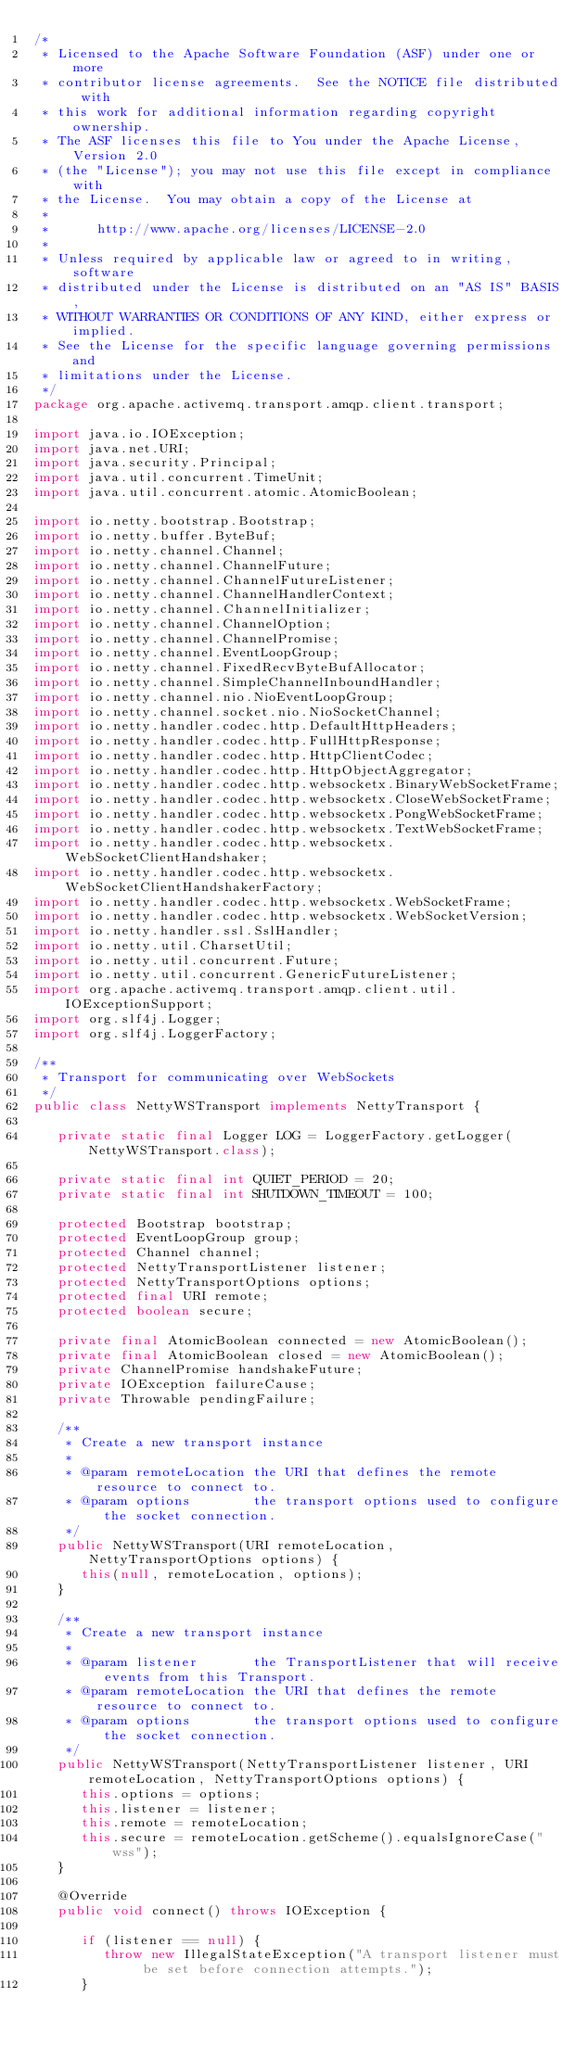<code> <loc_0><loc_0><loc_500><loc_500><_Java_>/*
 * Licensed to the Apache Software Foundation (ASF) under one or more
 * contributor license agreements.  See the NOTICE file distributed with
 * this work for additional information regarding copyright ownership.
 * The ASF licenses this file to You under the Apache License, Version 2.0
 * (the "License"); you may not use this file except in compliance with
 * the License.  You may obtain a copy of the License at
 *
 *      http://www.apache.org/licenses/LICENSE-2.0
 *
 * Unless required by applicable law or agreed to in writing, software
 * distributed under the License is distributed on an "AS IS" BASIS,
 * WITHOUT WARRANTIES OR CONDITIONS OF ANY KIND, either express or implied.
 * See the License for the specific language governing permissions and
 * limitations under the License.
 */
package org.apache.activemq.transport.amqp.client.transport;

import java.io.IOException;
import java.net.URI;
import java.security.Principal;
import java.util.concurrent.TimeUnit;
import java.util.concurrent.atomic.AtomicBoolean;

import io.netty.bootstrap.Bootstrap;
import io.netty.buffer.ByteBuf;
import io.netty.channel.Channel;
import io.netty.channel.ChannelFuture;
import io.netty.channel.ChannelFutureListener;
import io.netty.channel.ChannelHandlerContext;
import io.netty.channel.ChannelInitializer;
import io.netty.channel.ChannelOption;
import io.netty.channel.ChannelPromise;
import io.netty.channel.EventLoopGroup;
import io.netty.channel.FixedRecvByteBufAllocator;
import io.netty.channel.SimpleChannelInboundHandler;
import io.netty.channel.nio.NioEventLoopGroup;
import io.netty.channel.socket.nio.NioSocketChannel;
import io.netty.handler.codec.http.DefaultHttpHeaders;
import io.netty.handler.codec.http.FullHttpResponse;
import io.netty.handler.codec.http.HttpClientCodec;
import io.netty.handler.codec.http.HttpObjectAggregator;
import io.netty.handler.codec.http.websocketx.BinaryWebSocketFrame;
import io.netty.handler.codec.http.websocketx.CloseWebSocketFrame;
import io.netty.handler.codec.http.websocketx.PongWebSocketFrame;
import io.netty.handler.codec.http.websocketx.TextWebSocketFrame;
import io.netty.handler.codec.http.websocketx.WebSocketClientHandshaker;
import io.netty.handler.codec.http.websocketx.WebSocketClientHandshakerFactory;
import io.netty.handler.codec.http.websocketx.WebSocketFrame;
import io.netty.handler.codec.http.websocketx.WebSocketVersion;
import io.netty.handler.ssl.SslHandler;
import io.netty.util.CharsetUtil;
import io.netty.util.concurrent.Future;
import io.netty.util.concurrent.GenericFutureListener;
import org.apache.activemq.transport.amqp.client.util.IOExceptionSupport;
import org.slf4j.Logger;
import org.slf4j.LoggerFactory;

/**
 * Transport for communicating over WebSockets
 */
public class NettyWSTransport implements NettyTransport {

   private static final Logger LOG = LoggerFactory.getLogger(NettyWSTransport.class);

   private static final int QUIET_PERIOD = 20;
   private static final int SHUTDOWN_TIMEOUT = 100;

   protected Bootstrap bootstrap;
   protected EventLoopGroup group;
   protected Channel channel;
   protected NettyTransportListener listener;
   protected NettyTransportOptions options;
   protected final URI remote;
   protected boolean secure;

   private final AtomicBoolean connected = new AtomicBoolean();
   private final AtomicBoolean closed = new AtomicBoolean();
   private ChannelPromise handshakeFuture;
   private IOException failureCause;
   private Throwable pendingFailure;

   /**
    * Create a new transport instance
    *
    * @param remoteLocation the URI that defines the remote resource to connect to.
    * @param options        the transport options used to configure the socket connection.
    */
   public NettyWSTransport(URI remoteLocation, NettyTransportOptions options) {
      this(null, remoteLocation, options);
   }

   /**
    * Create a new transport instance
    *
    * @param listener       the TransportListener that will receive events from this Transport.
    * @param remoteLocation the URI that defines the remote resource to connect to.
    * @param options        the transport options used to configure the socket connection.
    */
   public NettyWSTransport(NettyTransportListener listener, URI remoteLocation, NettyTransportOptions options) {
      this.options = options;
      this.listener = listener;
      this.remote = remoteLocation;
      this.secure = remoteLocation.getScheme().equalsIgnoreCase("wss");
   }

   @Override
   public void connect() throws IOException {

      if (listener == null) {
         throw new IllegalStateException("A transport listener must be set before connection attempts.");
      }
</code> 